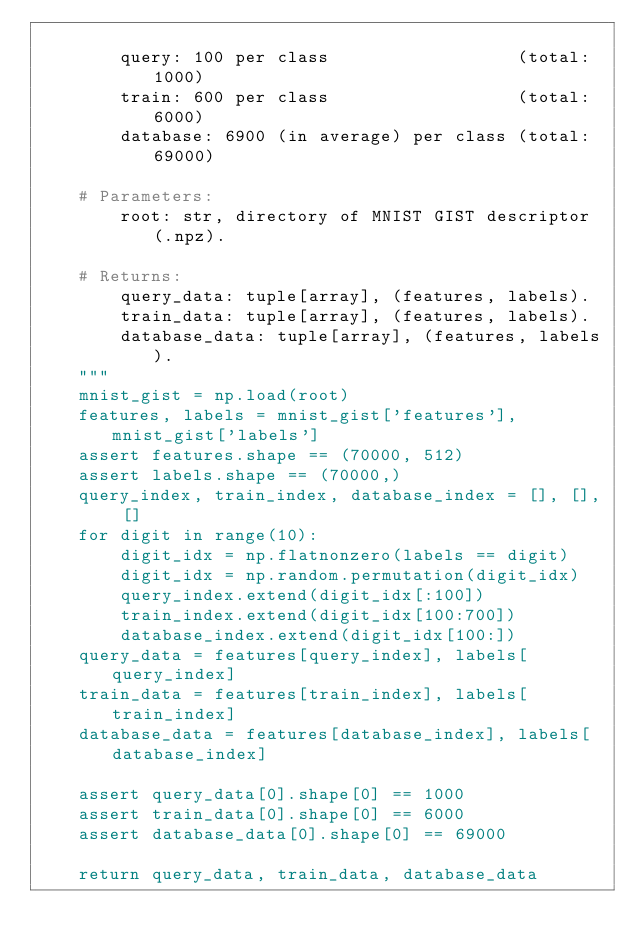<code> <loc_0><loc_0><loc_500><loc_500><_Python_>
        query: 100 per class                  (total: 1000)
        train: 600 per class                  (total: 6000)
        database: 6900 (in average) per class (total: 69000)

    # Parameters:
        root: str, directory of MNIST GIST descriptor (.npz).

    # Returns:
        query_data: tuple[array], (features, labels).
        train_data: tuple[array], (features, labels).
        database_data: tuple[array], (features, labels).
    """
    mnist_gist = np.load(root)
    features, labels = mnist_gist['features'], mnist_gist['labels']
    assert features.shape == (70000, 512)
    assert labels.shape == (70000,)
    query_index, train_index, database_index = [], [], []
    for digit in range(10):
        digit_idx = np.flatnonzero(labels == digit)
        digit_idx = np.random.permutation(digit_idx)
        query_index.extend(digit_idx[:100])
        train_index.extend(digit_idx[100:700])
        database_index.extend(digit_idx[100:])
    query_data = features[query_index], labels[query_index]
    train_data = features[train_index], labels[train_index]
    database_data = features[database_index], labels[database_index]

    assert query_data[0].shape[0] == 1000
    assert train_data[0].shape[0] == 6000
    assert database_data[0].shape[0] == 69000

    return query_data, train_data, database_data
</code> 